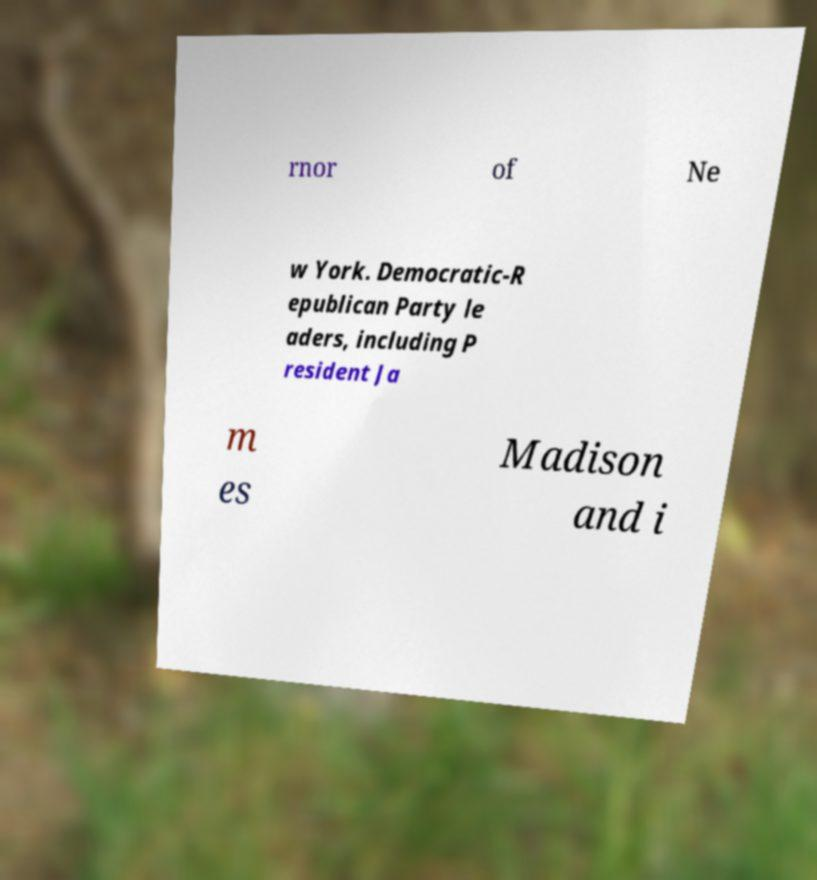Could you extract and type out the text from this image? rnor of Ne w York. Democratic-R epublican Party le aders, including P resident Ja m es Madison and i 